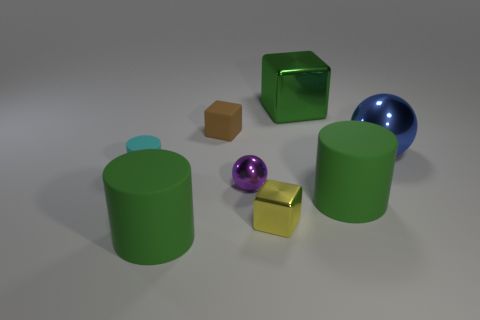There is a big rubber cylinder on the left side of the large green cube; is its color the same as the large block?
Keep it short and to the point. Yes. There is a matte object behind the small cyan cylinder; is its shape the same as the blue object?
Provide a succinct answer. No. The thing that is both to the right of the yellow metallic thing and in front of the purple metallic object is what color?
Your answer should be compact. Green. There is another object that is the same shape as the tiny purple metal object; what size is it?
Keep it short and to the point. Large. What number of rubber cubes have the same size as the yellow metallic thing?
Provide a succinct answer. 1. What size is the blue thing that is the same material as the large green cube?
Your answer should be very brief. Large. What number of cylinders are the same color as the large shiny cube?
Your answer should be very brief. 2. Are there fewer blue spheres left of the small yellow cube than shiny blocks in front of the cyan matte cylinder?
Give a very brief answer. Yes. There is a metallic ball that is behind the tiny cyan matte cylinder; what is its size?
Provide a short and direct response. Large. Is there a blue object made of the same material as the small ball?
Give a very brief answer. Yes. 